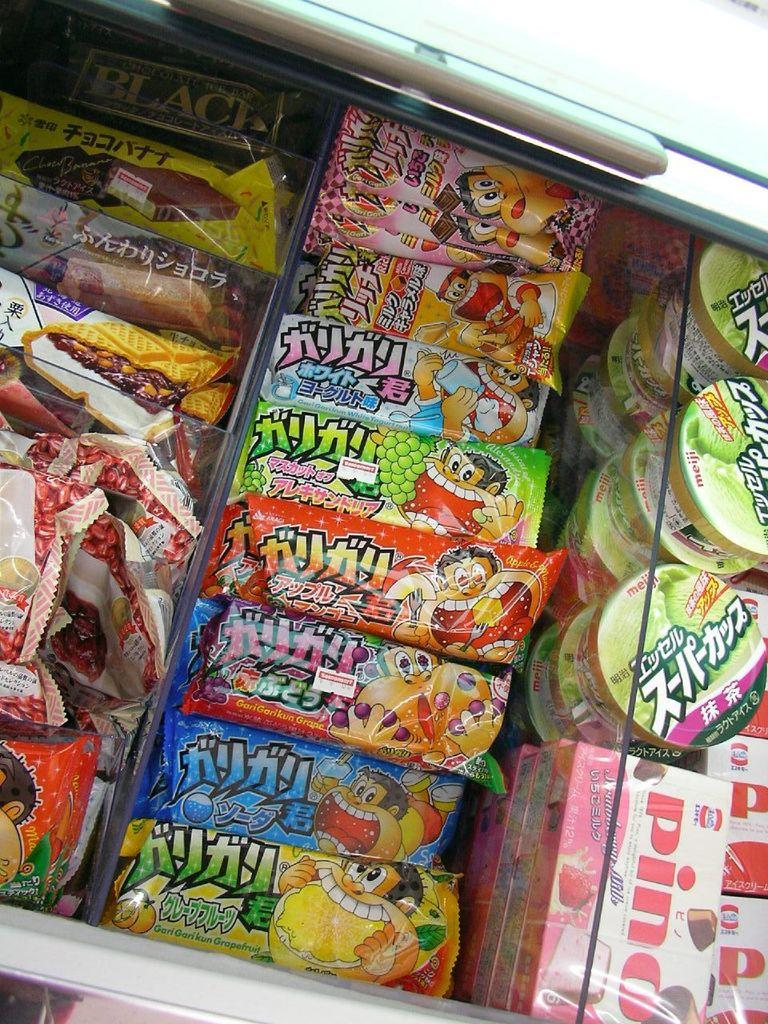<image>
Create a compact narrative representing the image presented. the word pino is on the pink item in the glass 